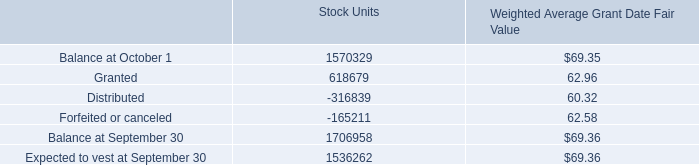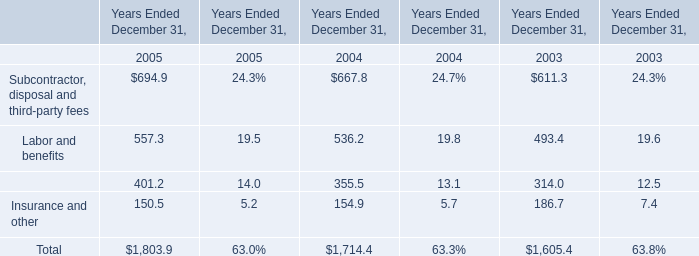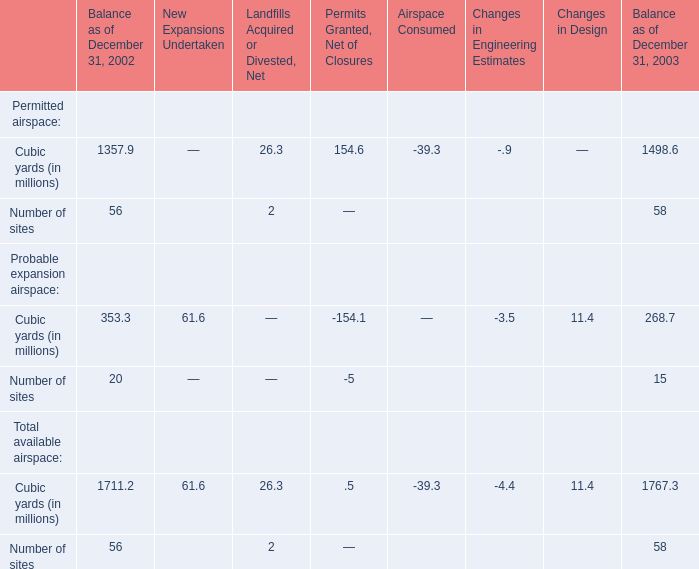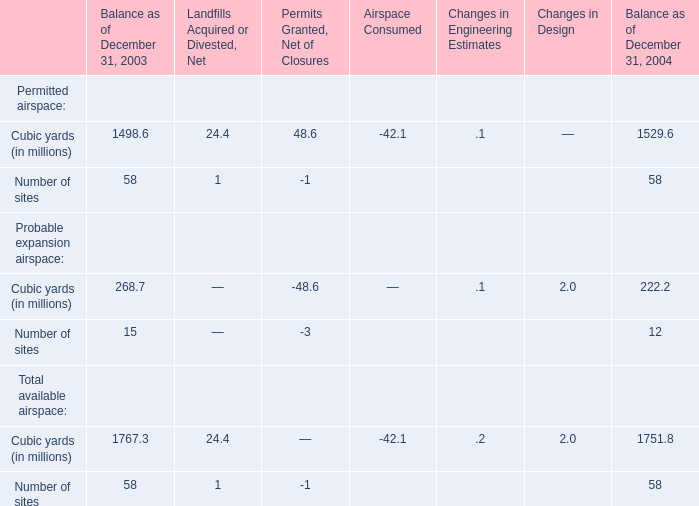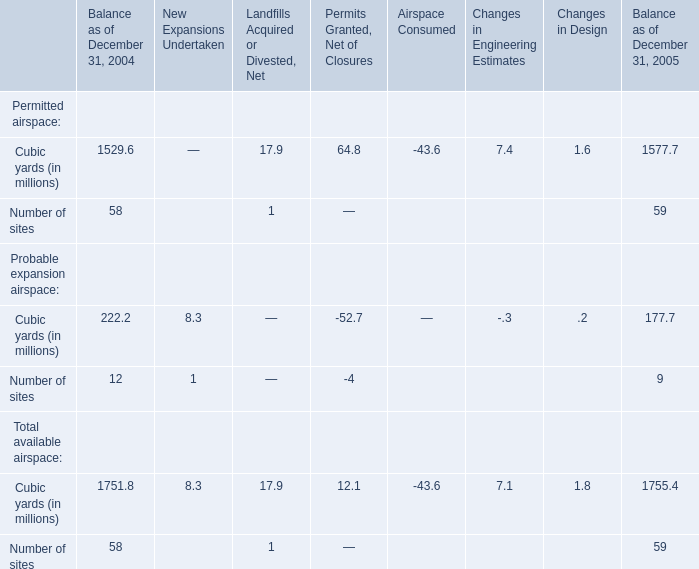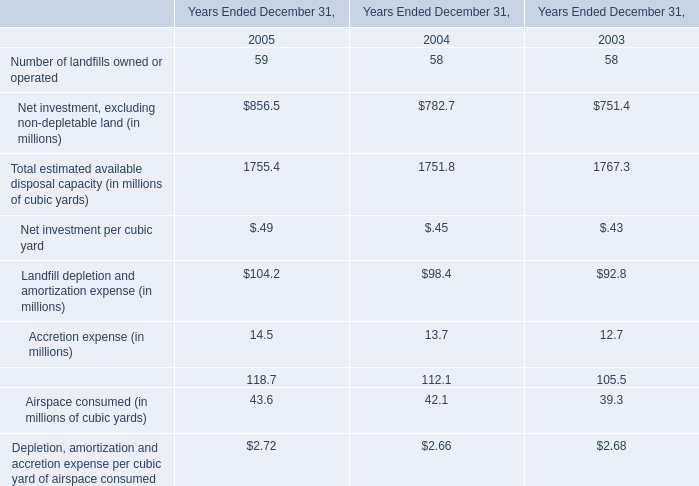What is the sum of Permitted airspace of Cubic yards (in millions) in Balance as of December 31, 2003? (in million) 
Computations: ((((1357.9 + 26.3) + 154.6) - 39.3) - 0.9)
Answer: 1498.6. 